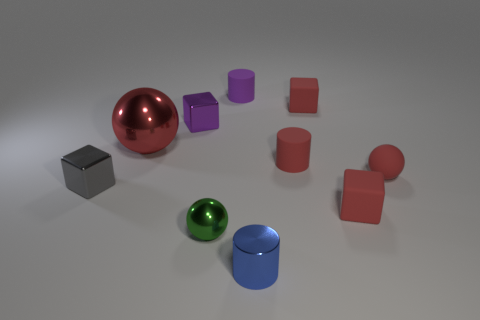Subtract all yellow cubes. Subtract all purple cylinders. How many cubes are left? 4 Subtract all cylinders. How many objects are left? 7 Subtract all metallic things. Subtract all big red metal cylinders. How many objects are left? 5 Add 2 tiny purple cubes. How many tiny purple cubes are left? 3 Add 1 small matte spheres. How many small matte spheres exist? 2 Subtract 1 blue cylinders. How many objects are left? 9 